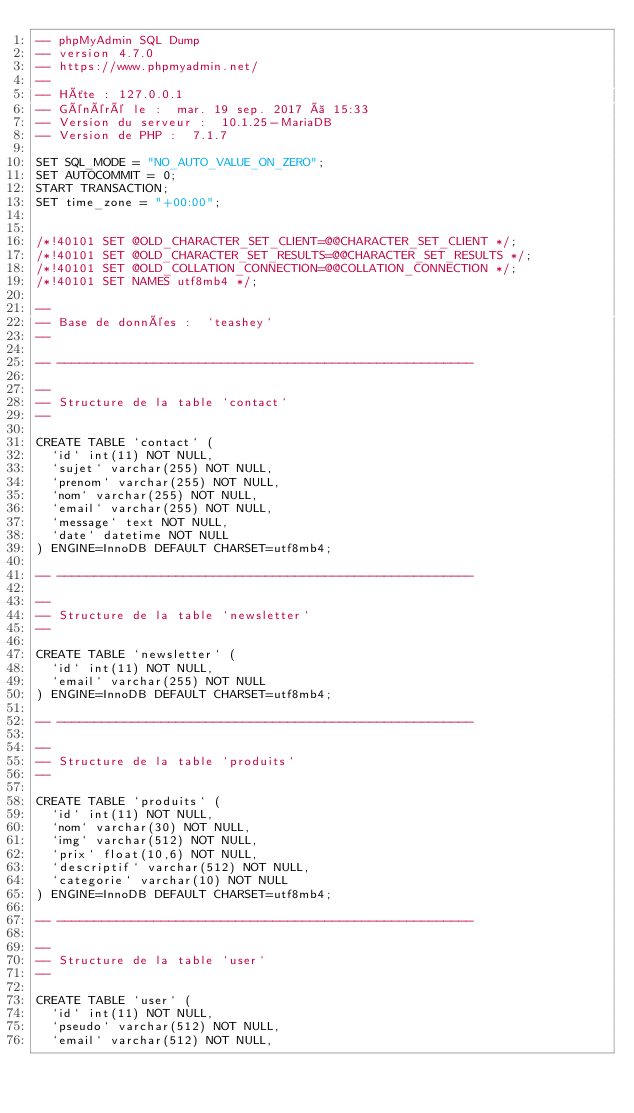<code> <loc_0><loc_0><loc_500><loc_500><_SQL_>-- phpMyAdmin SQL Dump
-- version 4.7.0
-- https://www.phpmyadmin.net/
--
-- Hôte : 127.0.0.1
-- Généré le :  mar. 19 sep. 2017 à 15:33
-- Version du serveur :  10.1.25-MariaDB
-- Version de PHP :  7.1.7

SET SQL_MODE = "NO_AUTO_VALUE_ON_ZERO";
SET AUTOCOMMIT = 0;
START TRANSACTION;
SET time_zone = "+00:00";


/*!40101 SET @OLD_CHARACTER_SET_CLIENT=@@CHARACTER_SET_CLIENT */;
/*!40101 SET @OLD_CHARACTER_SET_RESULTS=@@CHARACTER_SET_RESULTS */;
/*!40101 SET @OLD_COLLATION_CONNECTION=@@COLLATION_CONNECTION */;
/*!40101 SET NAMES utf8mb4 */;

--
-- Base de données :  `teashey`
--

-- --------------------------------------------------------

--
-- Structure de la table `contact`
--

CREATE TABLE `contact` (
  `id` int(11) NOT NULL,
  `sujet` varchar(255) NOT NULL,
  `prenom` varchar(255) NOT NULL,
  `nom` varchar(255) NOT NULL,
  `email` varchar(255) NOT NULL,
  `message` text NOT NULL,
  `date` datetime NOT NULL
) ENGINE=InnoDB DEFAULT CHARSET=utf8mb4;

-- --------------------------------------------------------

--
-- Structure de la table `newsletter`
--

CREATE TABLE `newsletter` (
  `id` int(11) NOT NULL,
  `email` varchar(255) NOT NULL
) ENGINE=InnoDB DEFAULT CHARSET=utf8mb4;

-- --------------------------------------------------------

--
-- Structure de la table `produits`
--

CREATE TABLE `produits` (
  `id` int(11) NOT NULL,
  `nom` varchar(30) NOT NULL,
  `img` varchar(512) NOT NULL,
  `prix` float(10,6) NOT NULL,
  `descriptif` varchar(512) NOT NULL,
  `categorie` varchar(10) NOT NULL
) ENGINE=InnoDB DEFAULT CHARSET=utf8mb4;

-- --------------------------------------------------------

--
-- Structure de la table `user`
--

CREATE TABLE `user` (
  `id` int(11) NOT NULL,
  `pseudo` varchar(512) NOT NULL,
  `email` varchar(512) NOT NULL,</code> 